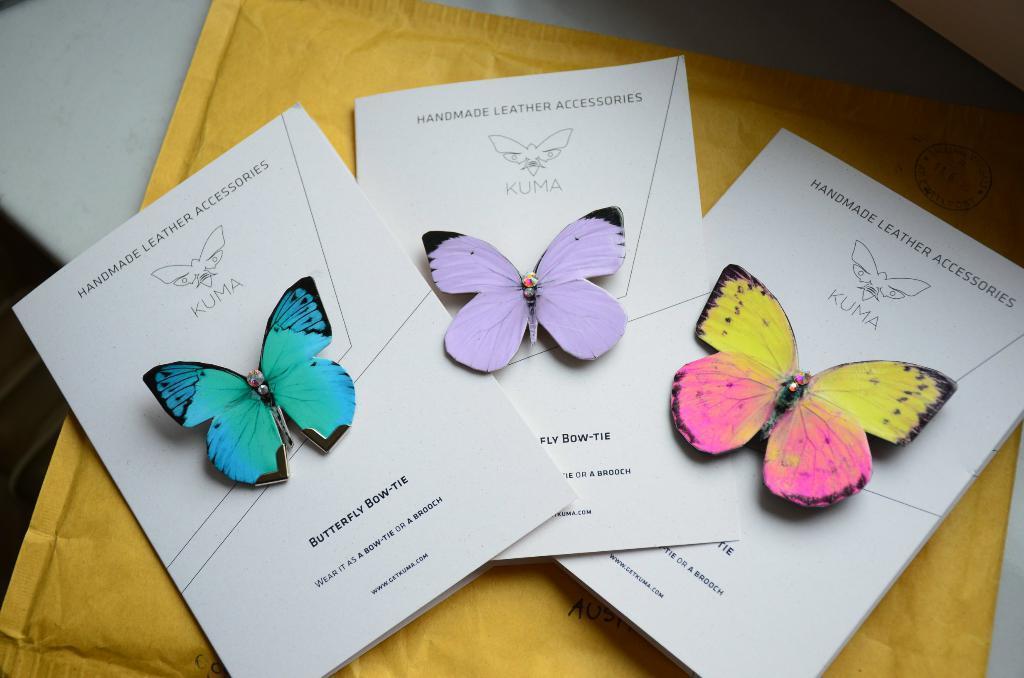How would you summarize this image in a sentence or two? In this image in the front there are papers with some text written on it and on the papers there are butterflies which are on yellow colour packet. All these things are kept on the surface which is white in colour. 